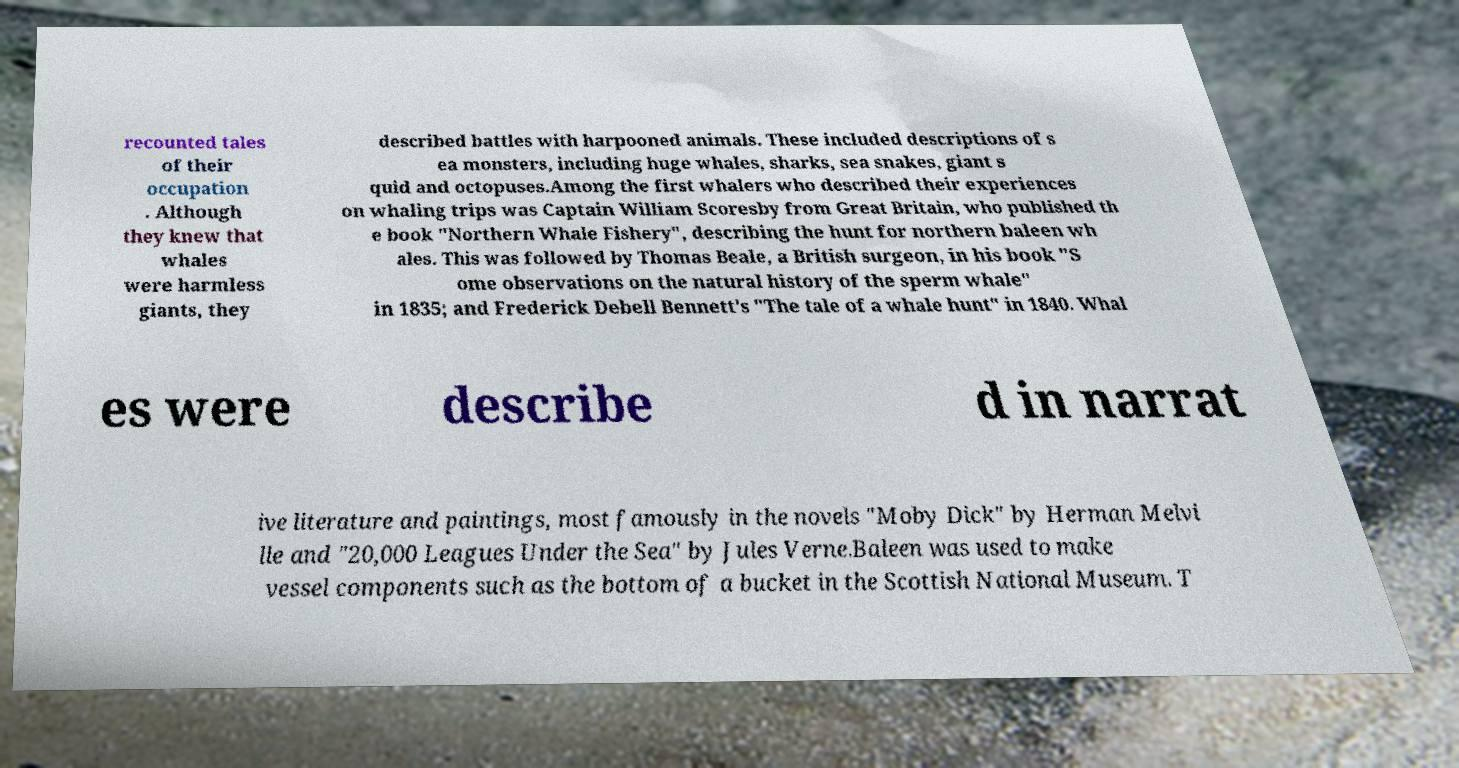What messages or text are displayed in this image? I need them in a readable, typed format. recounted tales of their occupation . Although they knew that whales were harmless giants, they described battles with harpooned animals. These included descriptions of s ea monsters, including huge whales, sharks, sea snakes, giant s quid and octopuses.Among the first whalers who described their experiences on whaling trips was Captain William Scoresby from Great Britain, who published th e book "Northern Whale Fishery", describing the hunt for northern baleen wh ales. This was followed by Thomas Beale, a British surgeon, in his book "S ome observations on the natural history of the sperm whale" in 1835; and Frederick Debell Bennett's "The tale of a whale hunt" in 1840. Whal es were describe d in narrat ive literature and paintings, most famously in the novels "Moby Dick" by Herman Melvi lle and "20,000 Leagues Under the Sea" by Jules Verne.Baleen was used to make vessel components such as the bottom of a bucket in the Scottish National Museum. T 